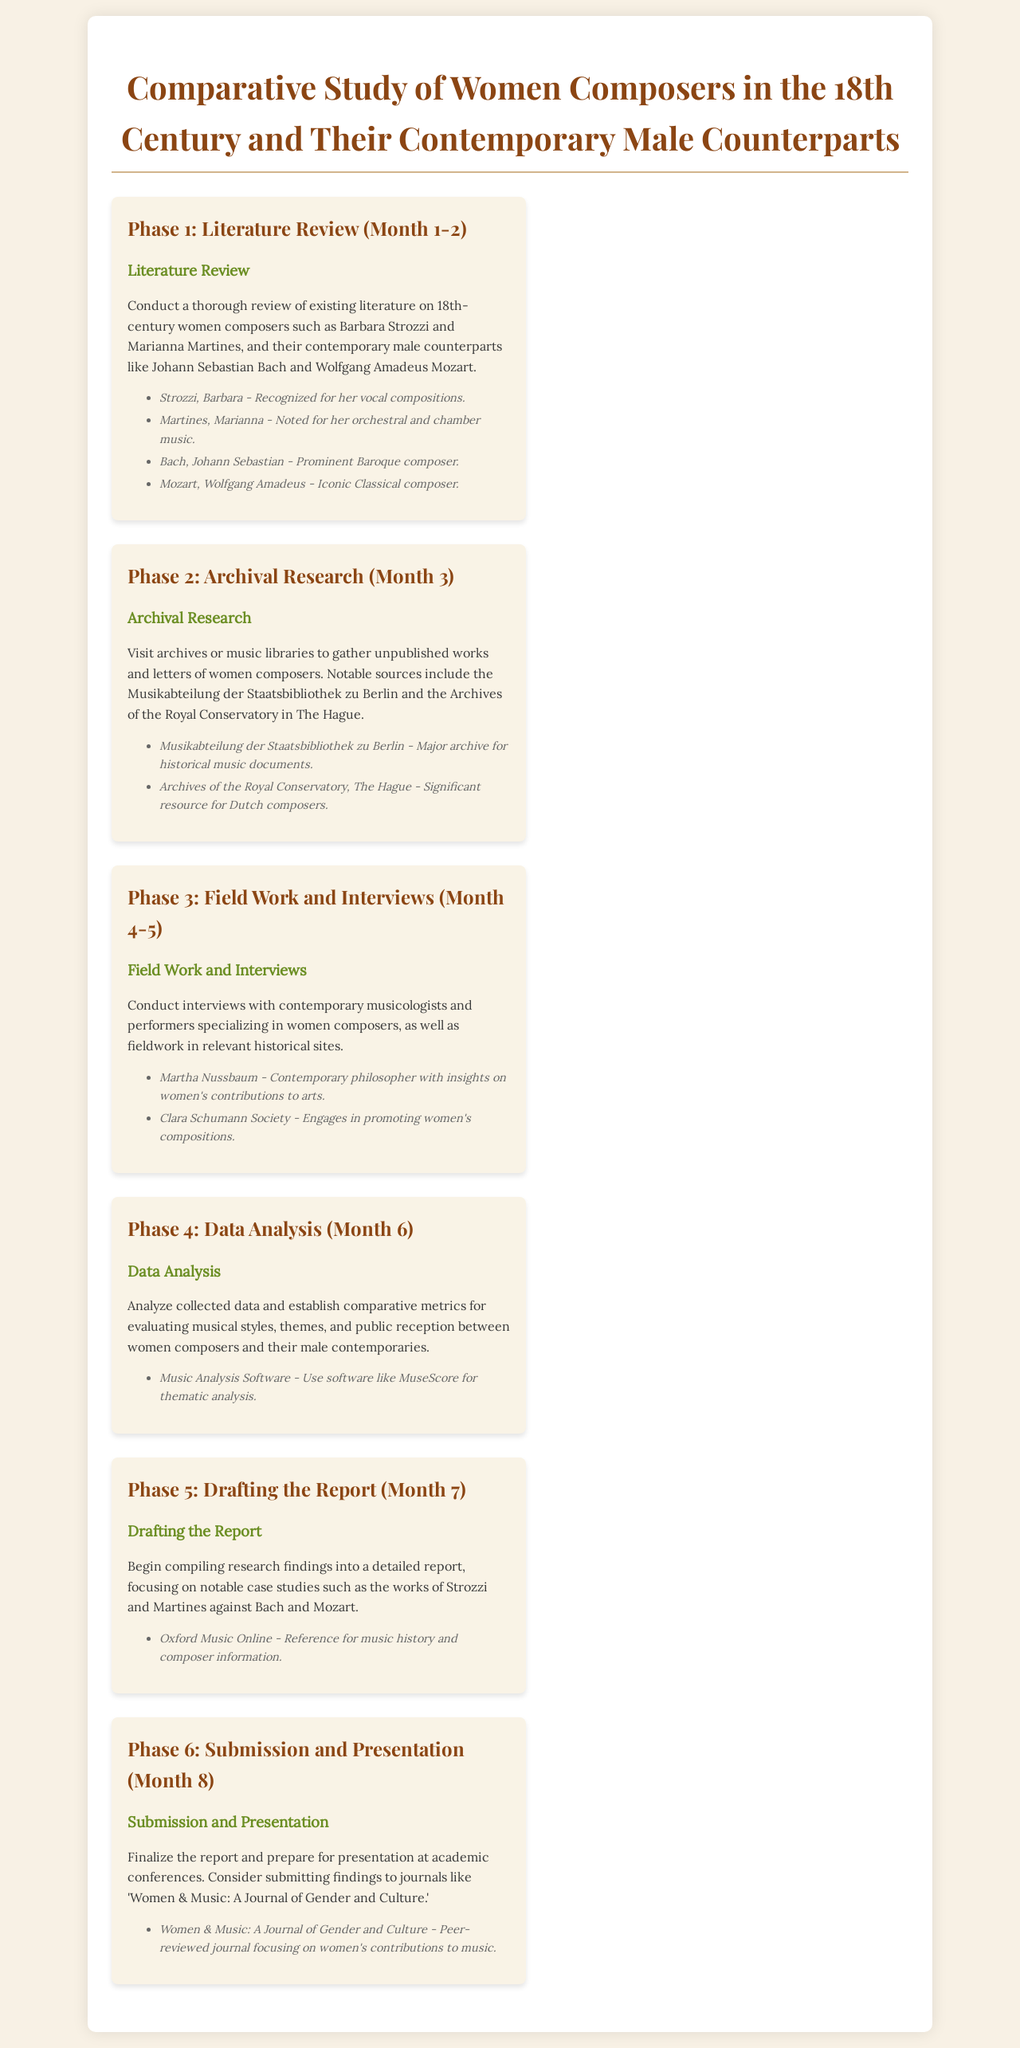What is Phase 1 of the project? Phase 1 is focused on conducting a thorough review of existing literature on 18th-century women composers and their contemporary male counterparts.
Answer: Literature Review Who are two women composers mentioned in Phase 1? The document lists Barbara Strozzi and Marianna Martines as notable women composers in Phase 1.
Answer: Barbara Strozzi, Marianna Martines What is the main activity in Phase 2? The main activity in Phase 2 is visiting archives or music libraries to gather unpublished works and letters of women composers.
Answer: Archival Research What significant archive is mentioned in Phase 2? The Musikabteilung der Staatsbibliothek zu Berlin is highlighted as a major archive for historical music documents.
Answer: Musikabteilung der Staatsbibliothek zu Berlin What is the primary goal of Phase 4? The primary goal of Phase 4 is to analyze collected data and establish comparative metrics for evaluating musical styles and themes.
Answer: Data Analysis What is a key focus of the drafting process in Phase 5? The drafting process focuses on compiling research findings into a detailed report, particularly on notable case studies.
Answer: Notable case studies In which month is the final report due? The final report is to be submitted and presented in Month 8.
Answer: Month 8 Which journal is mentioned for potential submission in Phase 6? The document suggests submitting findings to the journal 'Women & Music: A Journal of Gender and Culture.'
Answer: Women & Music: A Journal of Gender and Culture 